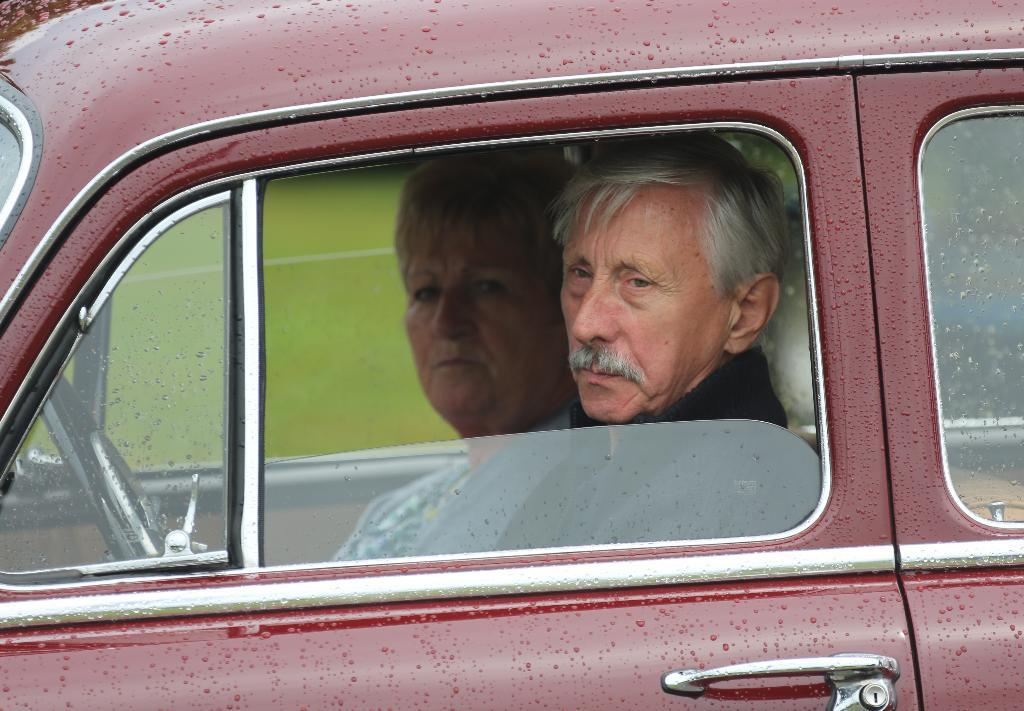What color is the car in the image? The car in the image is red. Who is inside the car? A lady and a man are sitting in the car. Can you describe the position of the people in the car? The lady and the man are both sitting in the car. What type of letter is the lady holding in the image? There is no letter present in the image; the lady is sitting in the car without holding anything. 